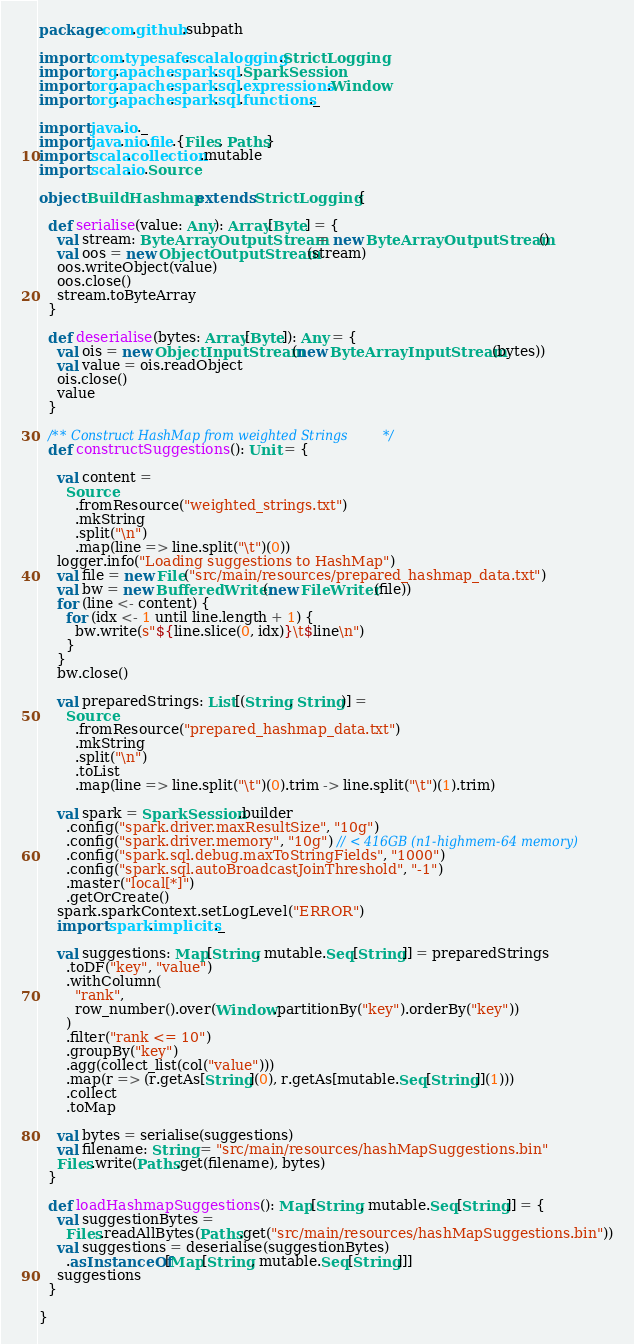Convert code to text. <code><loc_0><loc_0><loc_500><loc_500><_Scala_>package com.github.subpath

import com.typesafe.scalalogging.StrictLogging
import org.apache.spark.sql.SparkSession
import org.apache.spark.sql.expressions.Window
import org.apache.spark.sql.functions._

import java.io._
import java.nio.file.{Files, Paths}
import scala.collection.mutable
import scala.io.Source

object BuildHashmap extends StrictLogging {

  def serialise(value: Any): Array[Byte] = {
    val stream: ByteArrayOutputStream = new ByteArrayOutputStream()
    val oos = new ObjectOutputStream(stream)
    oos.writeObject(value)
    oos.close()
    stream.toByteArray
  }

  def deserialise(bytes: Array[Byte]): Any = {
    val ois = new ObjectInputStream(new ByteArrayInputStream(bytes))
    val value = ois.readObject
    ois.close()
    value
  }

  /** Construct HashMap from weighted Strings */
  def constructSuggestions(): Unit = {

    val content =
      Source
        .fromResource("weighted_strings.txt")
        .mkString
        .split("\n")
        .map(line => line.split("\t")(0))
    logger.info("Loading suggestions to HashMap")
    val file = new File("src/main/resources/prepared_hashmap_data.txt")
    val bw = new BufferedWriter(new FileWriter(file))
    for (line <- content) {
      for (idx <- 1 until line.length + 1) {
        bw.write(s"${line.slice(0, idx)}\t$line\n")
      }
    }
    bw.close()

    val preparedStrings: List[(String, String)] =
      Source
        .fromResource("prepared_hashmap_data.txt")
        .mkString
        .split("\n")
        .toList
        .map(line => line.split("\t")(0).trim -> line.split("\t")(1).trim)

    val spark = SparkSession.builder
      .config("spark.driver.maxResultSize", "10g")
      .config("spark.driver.memory", "10g") // < 416GB (n1-highmem-64 memory)
      .config("spark.sql.debug.maxToStringFields", "1000")
      .config("spark.sql.autoBroadcastJoinThreshold", "-1")
      .master("local[*]")
      .getOrCreate()
    spark.sparkContext.setLogLevel("ERROR")
    import spark.implicits._

    val suggestions: Map[String, mutable.Seq[String]] = preparedStrings
      .toDF("key", "value")
      .withColumn(
        "rank",
        row_number().over(Window.partitionBy("key").orderBy("key"))
      )
      .filter("rank <= 10")
      .groupBy("key")
      .agg(collect_list(col("value")))
      .map(r => (r.getAs[String](0), r.getAs[mutable.Seq[String]](1)))
      .collect
      .toMap

    val bytes = serialise(suggestions)
    val filename: String = "src/main/resources/hashMapSuggestions.bin"
    Files.write(Paths.get(filename), bytes)
  }

  def loadHashmapSuggestions(): Map[String, mutable.Seq[String]] = {
    val suggestionBytes =
      Files.readAllBytes(Paths.get("src/main/resources/hashMapSuggestions.bin"))
    val suggestions = deserialise(suggestionBytes)
      .asInstanceOf[Map[String, mutable.Seq[String]]]
    suggestions
  }

}
</code> 